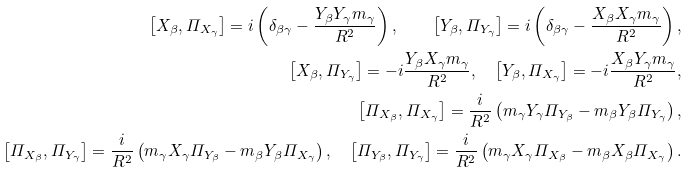Convert formula to latex. <formula><loc_0><loc_0><loc_500><loc_500>\left [ X _ { \beta } , \varPi _ { X _ { \gamma } } \right ] = i \left ( \delta _ { \beta \gamma } - \frac { Y _ { \beta } Y _ { \gamma } m _ { \gamma } } { R ^ { 2 } } \right ) , \quad \left [ Y _ { \beta } , \varPi _ { Y _ { \gamma } } \right ] = i \left ( \delta _ { \beta \gamma } - \frac { X _ { \beta } X _ { \gamma } m _ { \gamma } } { R ^ { 2 } } \right ) , \\ \left [ X _ { \beta } , \varPi _ { Y _ { \gamma } } \right ] = - i \frac { Y _ { \beta } X _ { \gamma } m _ { \gamma } } { R ^ { 2 } } , \quad \left [ Y _ { \beta } , \varPi _ { X _ { \gamma } } \right ] = - i \frac { X _ { \beta } Y _ { \gamma } m _ { \gamma } } { R ^ { 2 } } , \\ \left [ \varPi _ { X _ { \beta } } , \varPi _ { X _ { \gamma } } \right ] = \frac { i } { R ^ { 2 } } \left ( m _ { \gamma } Y _ { \gamma } \varPi _ { Y _ { \beta } } - m _ { \beta } Y _ { \beta } \varPi _ { Y _ { \gamma } } \right ) , \\ \left [ \varPi _ { X _ { \beta } } , \varPi _ { Y _ { \gamma } } \right ] = \frac { i } { R ^ { 2 } } \left ( m _ { \gamma } X _ { \gamma } \varPi _ { Y _ { \beta } } - m _ { \beta } Y _ { \beta } \varPi _ { X _ { \gamma } } \right ) , \quad \left [ \varPi _ { Y _ { \beta } } , \varPi _ { Y _ { \gamma } } \right ] = \frac { i } { R ^ { 2 } } \left ( m _ { \gamma } X _ { \gamma } \varPi _ { X _ { \beta } } - m _ { \beta } X _ { \beta } \varPi _ { X _ { \gamma } } \right ) .</formula> 